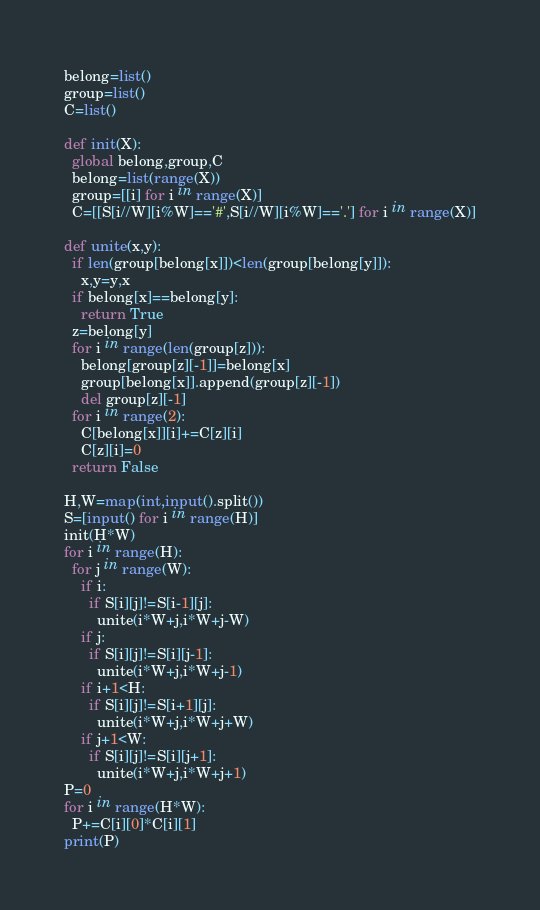Convert code to text. <code><loc_0><loc_0><loc_500><loc_500><_Python_>belong=list()
group=list()
C=list()

def init(X):
  global belong,group,C
  belong=list(range(X))
  group=[[i] for i in range(X)]
  C=[[S[i//W][i%W]=='#',S[i//W][i%W]=='.'] for i in range(X)]

def unite(x,y):
  if len(group[belong[x]])<len(group[belong[y]]):
    x,y=y,x
  if belong[x]==belong[y]:
    return True
  z=belong[y]
  for i in range(len(group[z])):
    belong[group[z][-1]]=belong[x]
    group[belong[x]].append(group[z][-1])
    del group[z][-1]
  for i in range(2):
    C[belong[x]][i]+=C[z][i]
    C[z][i]=0
  return False

H,W=map(int,input().split())
S=[input() for i in range(H)]
init(H*W)
for i in range(H):
  for j in range(W):
    if i:
      if S[i][j]!=S[i-1][j]:
        unite(i*W+j,i*W+j-W)
    if j:
      if S[i][j]!=S[i][j-1]:
        unite(i*W+j,i*W+j-1)
    if i+1<H:
      if S[i][j]!=S[i+1][j]:
        unite(i*W+j,i*W+j+W)
    if j+1<W:
      if S[i][j]!=S[i][j+1]:
        unite(i*W+j,i*W+j+1)
P=0
for i in range(H*W):
  P+=C[i][0]*C[i][1]
print(P)</code> 